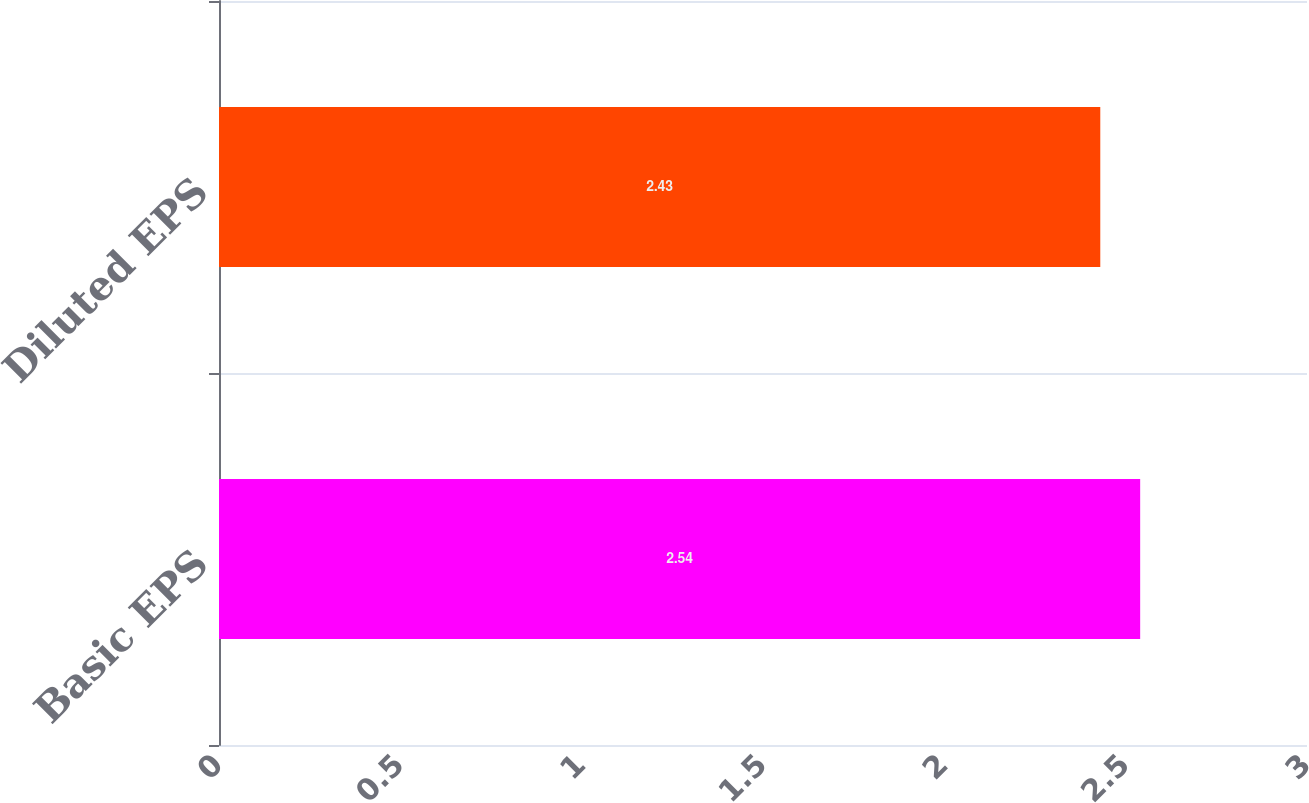Convert chart to OTSL. <chart><loc_0><loc_0><loc_500><loc_500><bar_chart><fcel>Basic EPS<fcel>Diluted EPS<nl><fcel>2.54<fcel>2.43<nl></chart> 